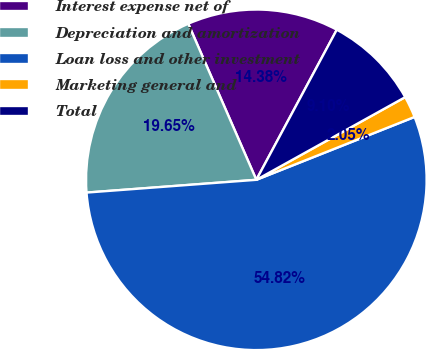Convert chart to OTSL. <chart><loc_0><loc_0><loc_500><loc_500><pie_chart><fcel>Interest expense net of<fcel>Depreciation and amortization<fcel>Loan loss and other investment<fcel>Marketing general and<fcel>Total<nl><fcel>14.38%<fcel>19.65%<fcel>54.83%<fcel>2.05%<fcel>9.1%<nl></chart> 